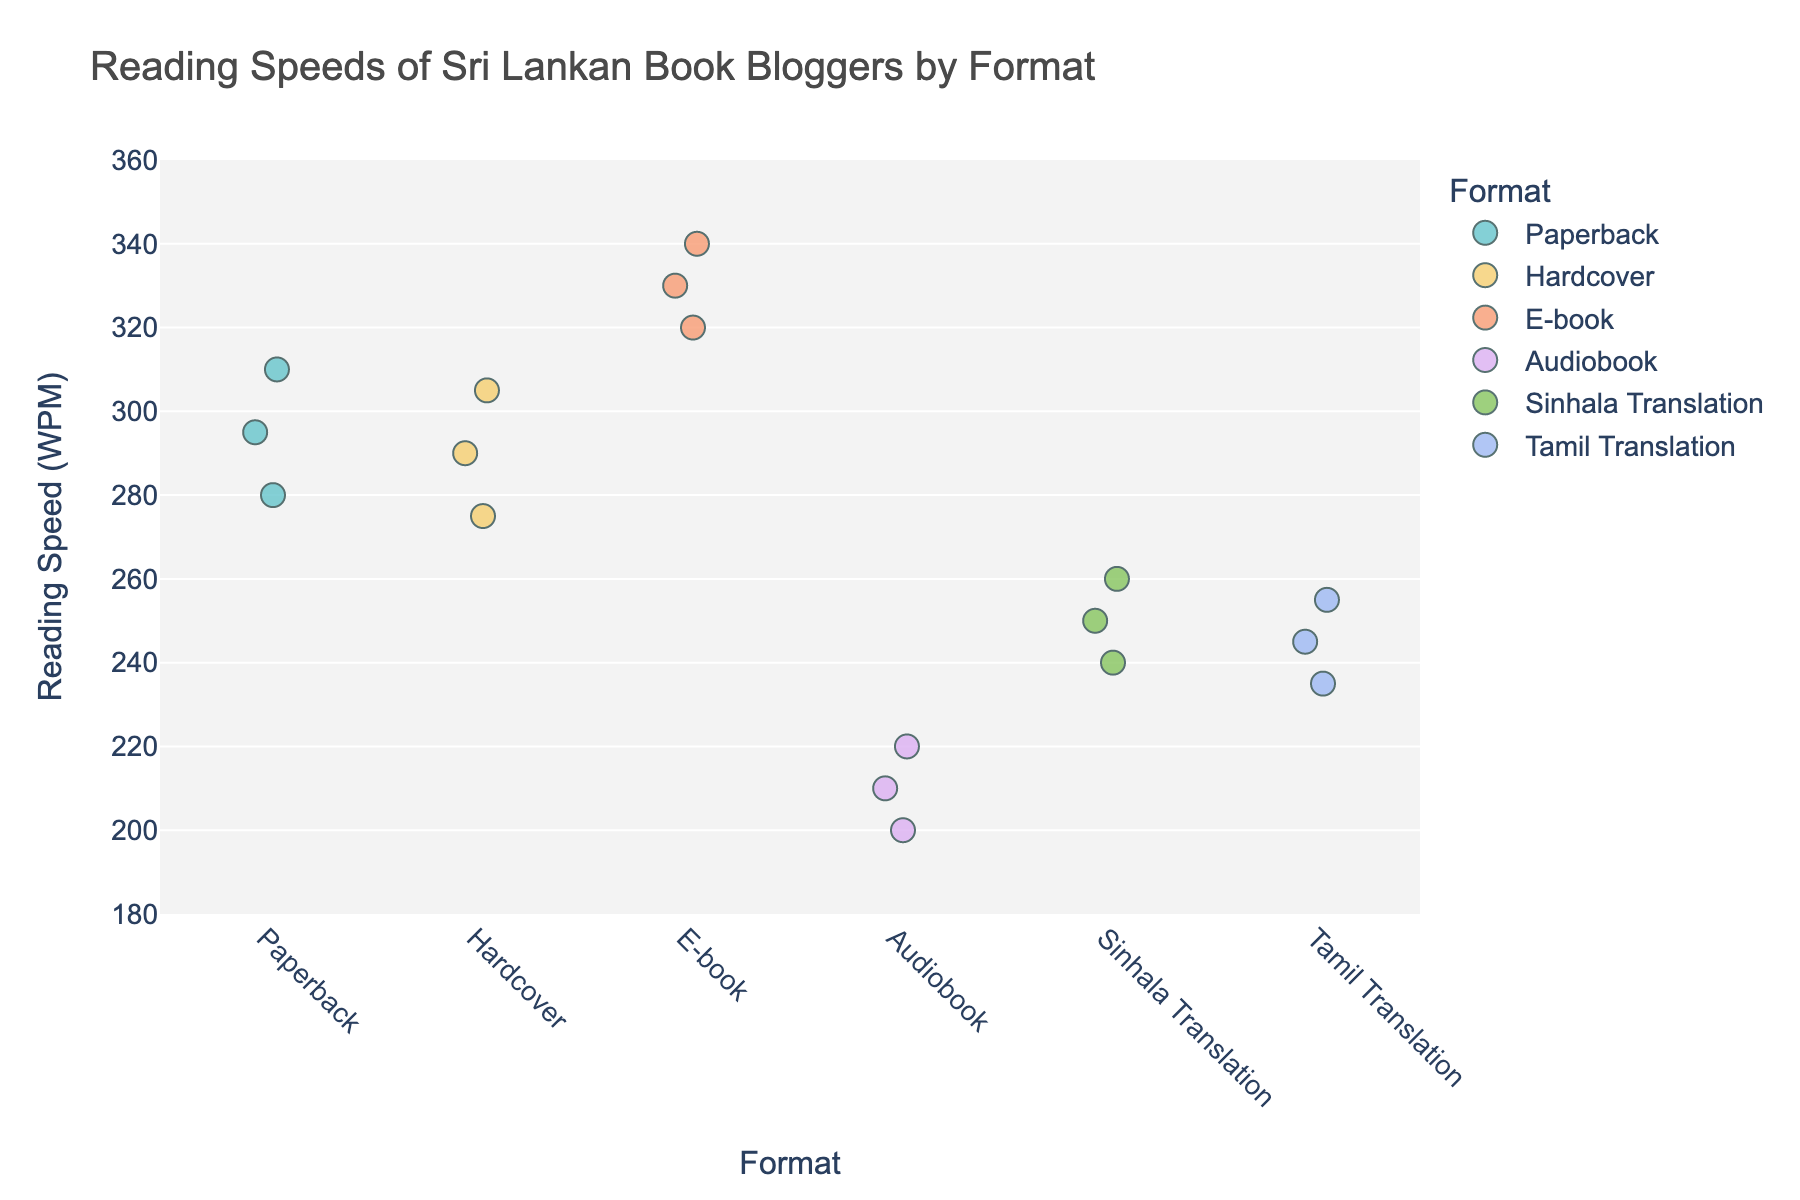what's the title of the plot? The title is displayed at the top of the plot.
Answer: Reading Speeds of Sri Lankan Book Bloggers by Format How many book formats are represented in the plot? Count the unique categories on the x-axis.
Answer: 6 What's the range of reading speeds in words per minute (WPM) displayed on the y-axis? Look at the y-axis labels from the minimum to maximum values.
Answer: 180 to 360 Which book format has the highest reading speed? Identify the topmost data points and their corresponding format on the x-axis.
Answer: E-book What's the average reading speed for the E-book format? The E-book reading speeds are 320, 340, and 330. Calculate the average: (320 + 340 + 330) / 3 = 990 / 3 = 330.
Answer: 330 How does the reading speed of Audiobooks compare to Paperbacks? Identify the range of reading speeds for both formats and compare them. The Audiobook speeds are 200, 220, and 210. The Paperback speeds are 280, 310, and 295. Audiobooks are consistently slower than Paperbacks.
Answer: Audiobooks are slower Which format shows the most variability in reading speeds? Look for the widest spread of data points among the formats. E-books have points from 320 to 340, but Paperbacks range from 280 to 310. Compare spreads of all formats.
Answer: Paperback What is the reading speed difference between the fastest and slowest book format? Find the highest reading speed point (E-book, 340) and the lowest (Audiobook, 200). The difference is 340 - 200 = 140.
Answer: 140 How do reading speeds for Sinhala and Tamil Translations compare? Identify the range of speeds for both formats. Sinhala Translation ranges from 240 to 260. Tamil Translation ranges from 235 to 255. Compare overlaps and differences.
Answer: Sinhala Translation is slightly faster What is the median reading speed for the Hardcover format? The reading speeds for Hardcover are 275, 305, and 290. Arrange them in order: 275, 290, 305. The middle value is 290.
Answer: 290 